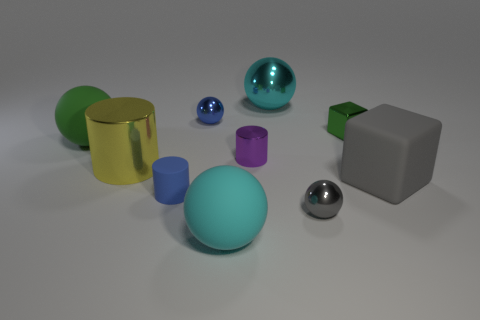What materials are the objects in the image made of, and which one looks the most reflective? The objects appear to be made from various materials that include rubber, metal, and possibly plastic. The large sphere in a teal hue, given its high reflectivity and visible surroundings on its surface, seems to be the most reflective object, likely made of polished metal. 